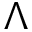Convert formula to latex. <formula><loc_0><loc_0><loc_500><loc_500>\Lambda</formula> 